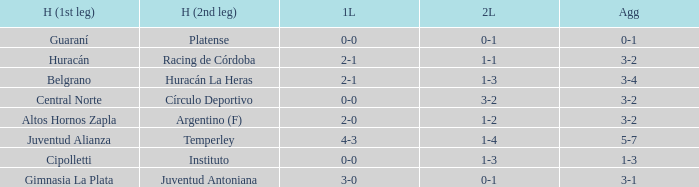What was the aggregate score that had a 1-2 second leg score? 3-2. 